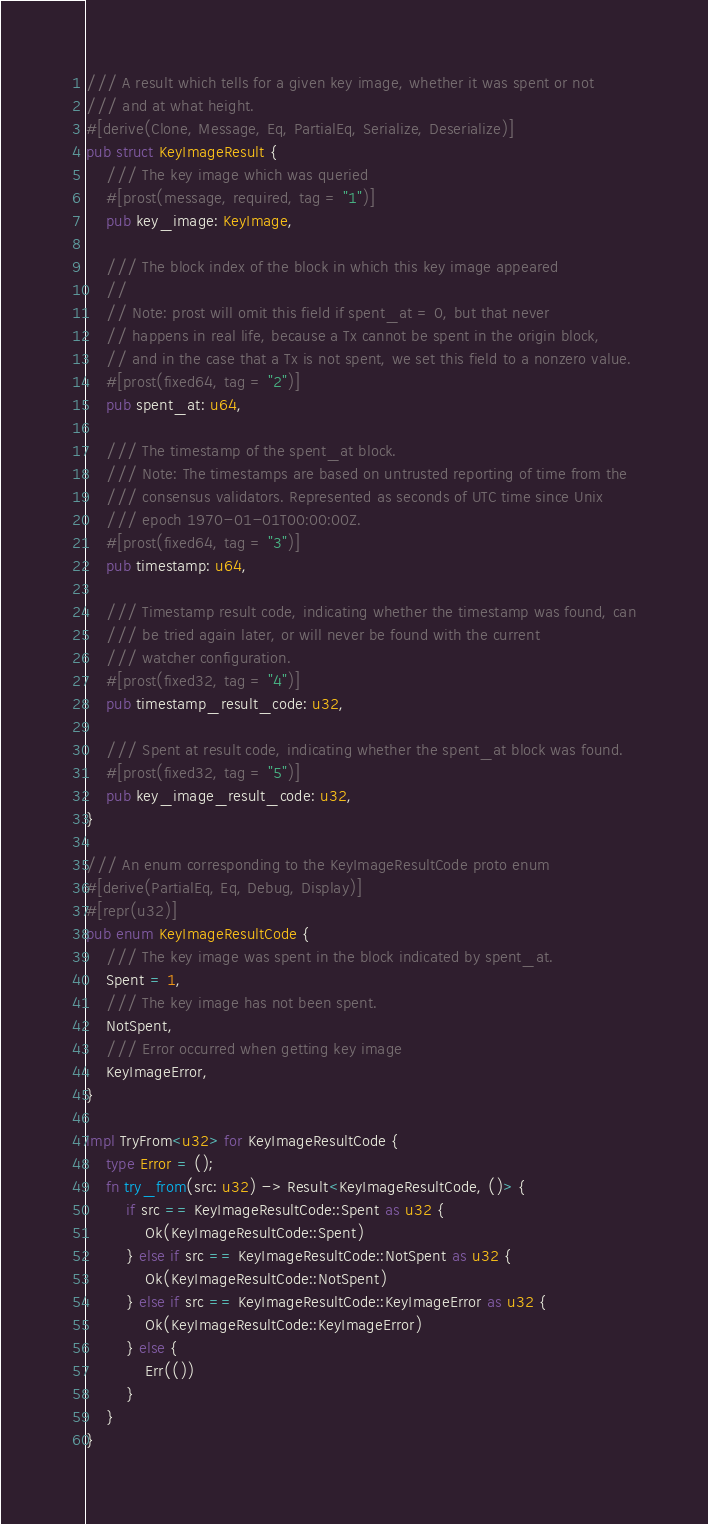<code> <loc_0><loc_0><loc_500><loc_500><_Rust_>
/// A result which tells for a given key image, whether it was spent or not
/// and at what height.
#[derive(Clone, Message, Eq, PartialEq, Serialize, Deserialize)]
pub struct KeyImageResult {
    /// The key image which was queried
    #[prost(message, required, tag = "1")]
    pub key_image: KeyImage,

    /// The block index of the block in which this key image appeared
    //
    // Note: prost will omit this field if spent_at = 0, but that never
    // happens in real life, because a Tx cannot be spent in the origin block,
    // and in the case that a Tx is not spent, we set this field to a nonzero value.
    #[prost(fixed64, tag = "2")]
    pub spent_at: u64,

    /// The timestamp of the spent_at block.
    /// Note: The timestamps are based on untrusted reporting of time from the
    /// consensus validators. Represented as seconds of UTC time since Unix
    /// epoch 1970-01-01T00:00:00Z.
    #[prost(fixed64, tag = "3")]
    pub timestamp: u64,

    /// Timestamp result code, indicating whether the timestamp was found, can
    /// be tried again later, or will never be found with the current
    /// watcher configuration.
    #[prost(fixed32, tag = "4")]
    pub timestamp_result_code: u32,

    /// Spent at result code, indicating whether the spent_at block was found.
    #[prost(fixed32, tag = "5")]
    pub key_image_result_code: u32,
}

/// An enum corresponding to the KeyImageResultCode proto enum
#[derive(PartialEq, Eq, Debug, Display)]
#[repr(u32)]
pub enum KeyImageResultCode {
    /// The key image was spent in the block indicated by spent_at.
    Spent = 1,
    /// The key image has not been spent.
    NotSpent,
    /// Error occurred when getting key image
    KeyImageError,
}

impl TryFrom<u32> for KeyImageResultCode {
    type Error = ();
    fn try_from(src: u32) -> Result<KeyImageResultCode, ()> {
        if src == KeyImageResultCode::Spent as u32 {
            Ok(KeyImageResultCode::Spent)
        } else if src == KeyImageResultCode::NotSpent as u32 {
            Ok(KeyImageResultCode::NotSpent)
        } else if src == KeyImageResultCode::KeyImageError as u32 {
            Ok(KeyImageResultCode::KeyImageError)
        } else {
            Err(())
        }
    }
}
</code> 